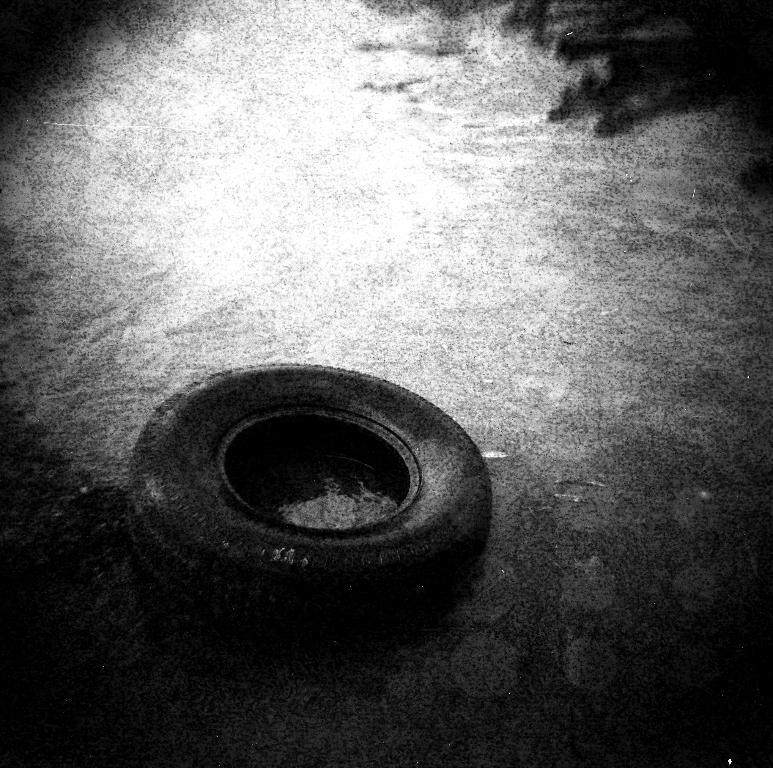What is the color scheme of the image? The image is black and white. Where was the image taken? The image was taken outdoors. What can be seen at the bottom of the image? There is a floor visible at the bottom of the image. What is the main object in the middle of the image? There is a tire in the middle of the image. How is the tire positioned in the image? The tire is on the floor. How many bells are hanging from the tire in the image? There are no bells present in the image; it only features a tire on the floor. What type of behavior can be observed in the chickens in the image? There are no chickens present in the image; it only features a tire on the floor. 